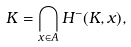Convert formula to latex. <formula><loc_0><loc_0><loc_500><loc_500>K = \bigcap _ { x \in A } H ^ { - } ( K , x ) ,</formula> 